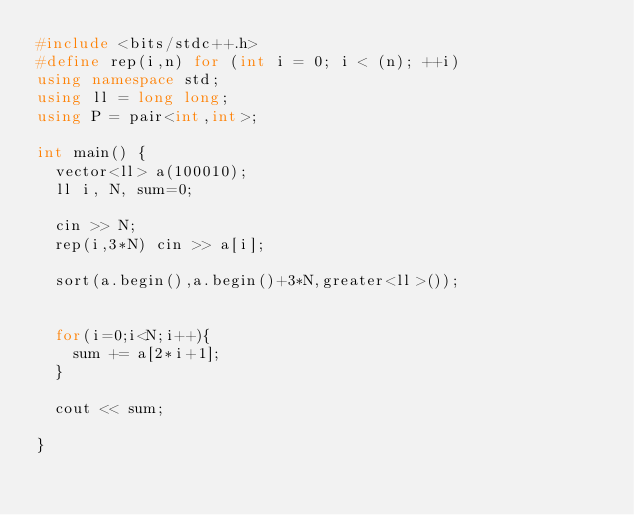Convert code to text. <code><loc_0><loc_0><loc_500><loc_500><_C++_>#include <bits/stdc++.h>
#define rep(i,n) for (int i = 0; i < (n); ++i)
using namespace std;
using ll = long long;
using P = pair<int,int>;

int main() {
  vector<ll> a(100010);
  ll i, N, sum=0;
  
  cin >> N;
  rep(i,3*N) cin >> a[i];
  
  sort(a.begin(),a.begin()+3*N,greater<ll>());
  
  
  for(i=0;i<N;i++){
    sum += a[2*i+1];
  }
  
  cout << sum;
  
}</code> 